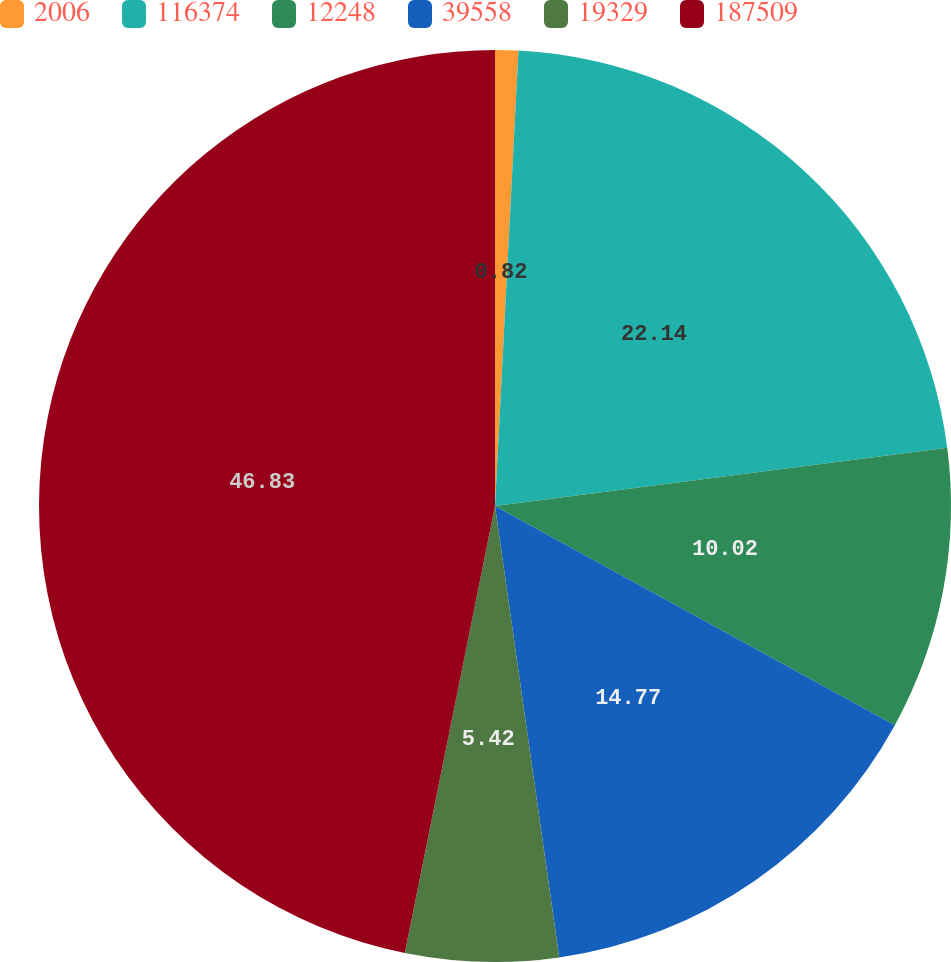Convert chart. <chart><loc_0><loc_0><loc_500><loc_500><pie_chart><fcel>2006<fcel>116374<fcel>12248<fcel>39558<fcel>19329<fcel>187509<nl><fcel>0.82%<fcel>22.14%<fcel>10.02%<fcel>14.77%<fcel>5.42%<fcel>46.83%<nl></chart> 